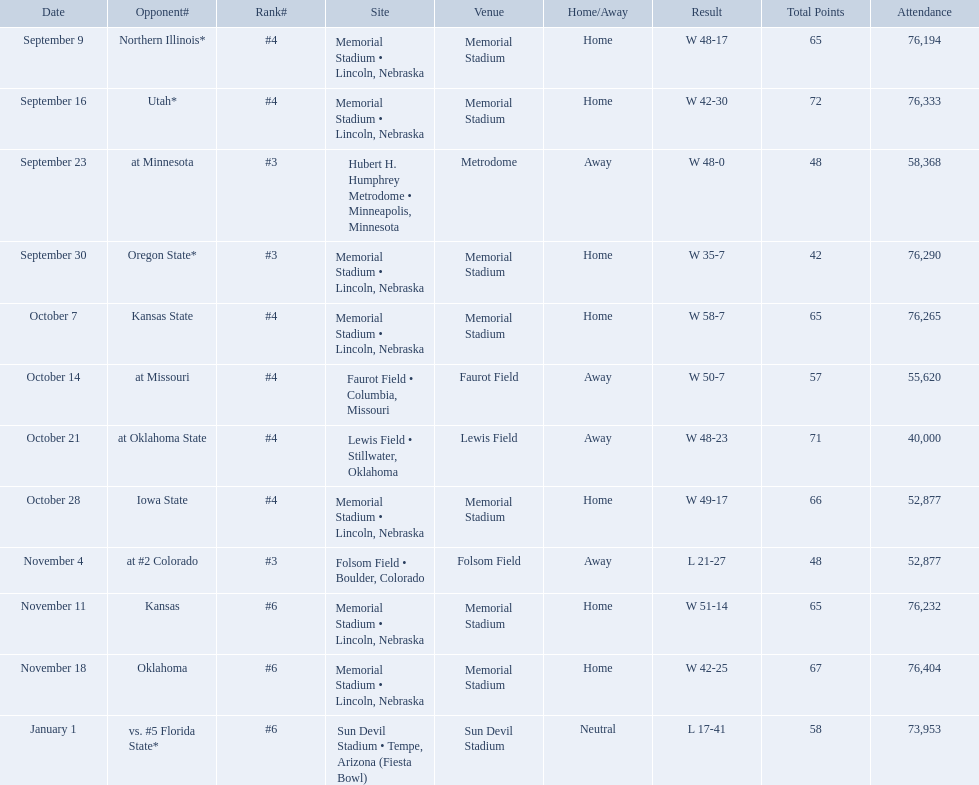When did nebraska play oregon state? September 30. What was the attendance at the september 30 game? 76,290. Who were all of their opponents? Northern Illinois*, Utah*, at Minnesota, Oregon State*, Kansas State, at Missouri, at Oklahoma State, Iowa State, at #2 Colorado, Kansas, Oklahoma, vs. #5 Florida State*. And what was the attendance of these games? 76,194, 76,333, 58,368, 76,290, 76,265, 55,620, 40,000, 52,877, 52,877, 76,232, 76,404, 73,953. Of those numbers, which is associated with the oregon state game? 76,290. 